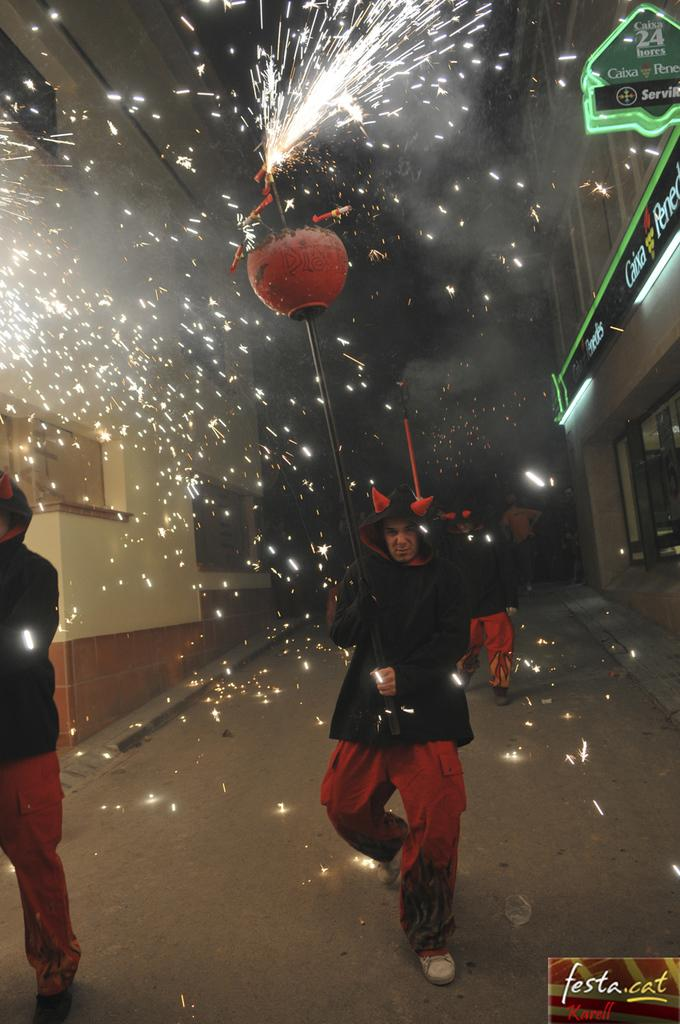What is happening with the group of people in the image? The people are walking on the road in the image. What are some of the people holding? Some people are holding metal rods in the image. What can be seen in the background of the image? There are houses, lights, and hoardings in the background of the image. What type of art can be seen on the grip of the metal rods? There is no art visible on the grip of the metal rods in the image, as the focus is on the people walking and holding the rods. 